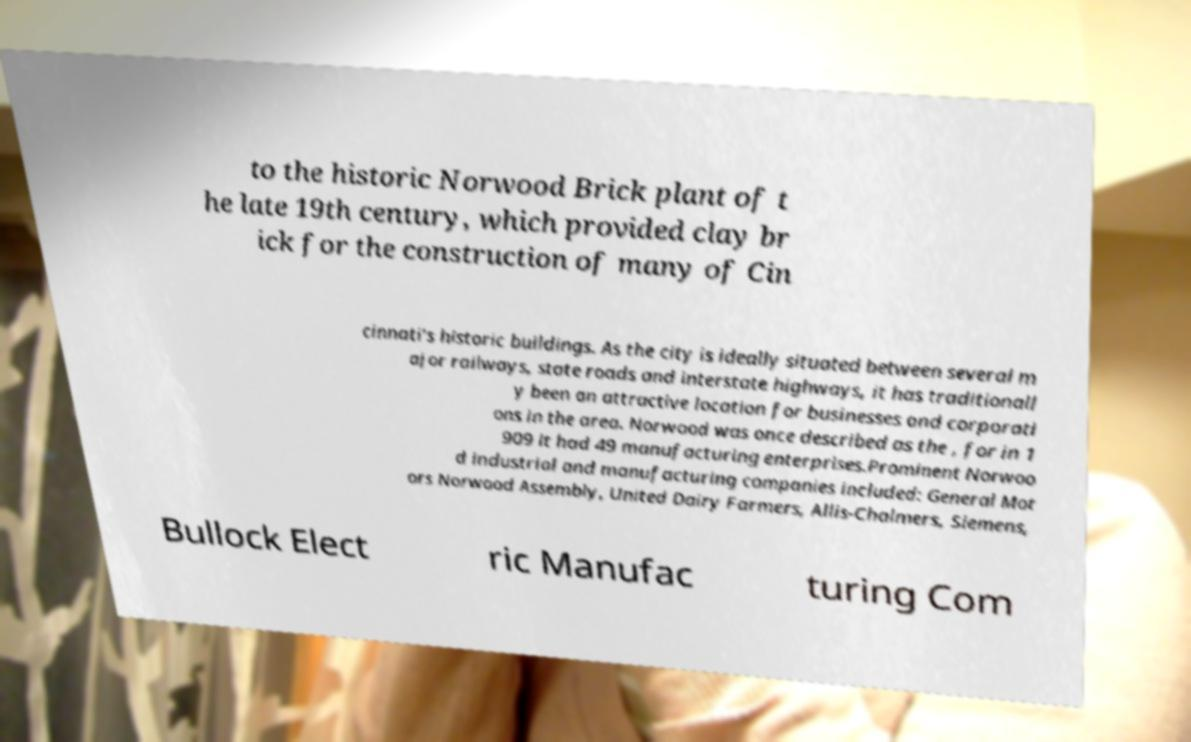Can you read and provide the text displayed in the image?This photo seems to have some interesting text. Can you extract and type it out for me? to the historic Norwood Brick plant of t he late 19th century, which provided clay br ick for the construction of many of Cin cinnati's historic buildings. As the city is ideally situated between several m ajor railways, state roads and interstate highways, it has traditionall y been an attractive location for businesses and corporati ons in the area. Norwood was once described as the , for in 1 909 it had 49 manufacturing enterprises.Prominent Norwoo d industrial and manufacturing companies included: General Mot ors Norwood Assembly, United Dairy Farmers, Allis-Chalmers, Siemens, Bullock Elect ric Manufac turing Com 